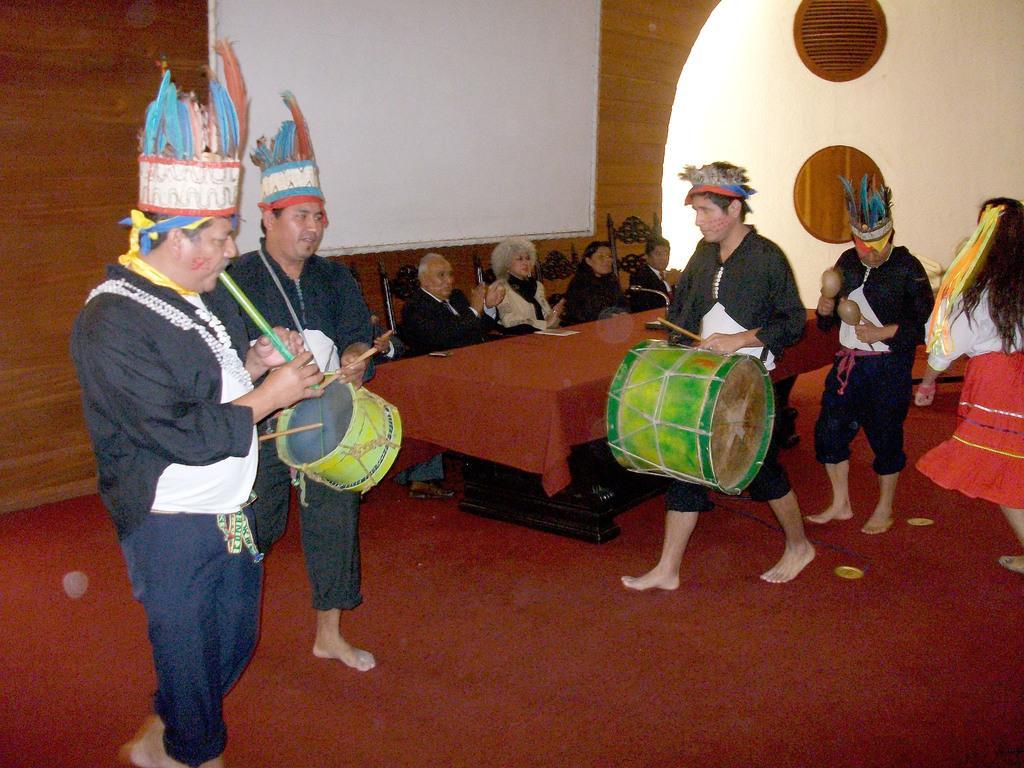Could you give a brief overview of what you see in this image? In this image there are group of people. Few people are sitting on chair and remaining few are playing their musical instruments. In background there is a white color screen at bottom there is a red color mat. 